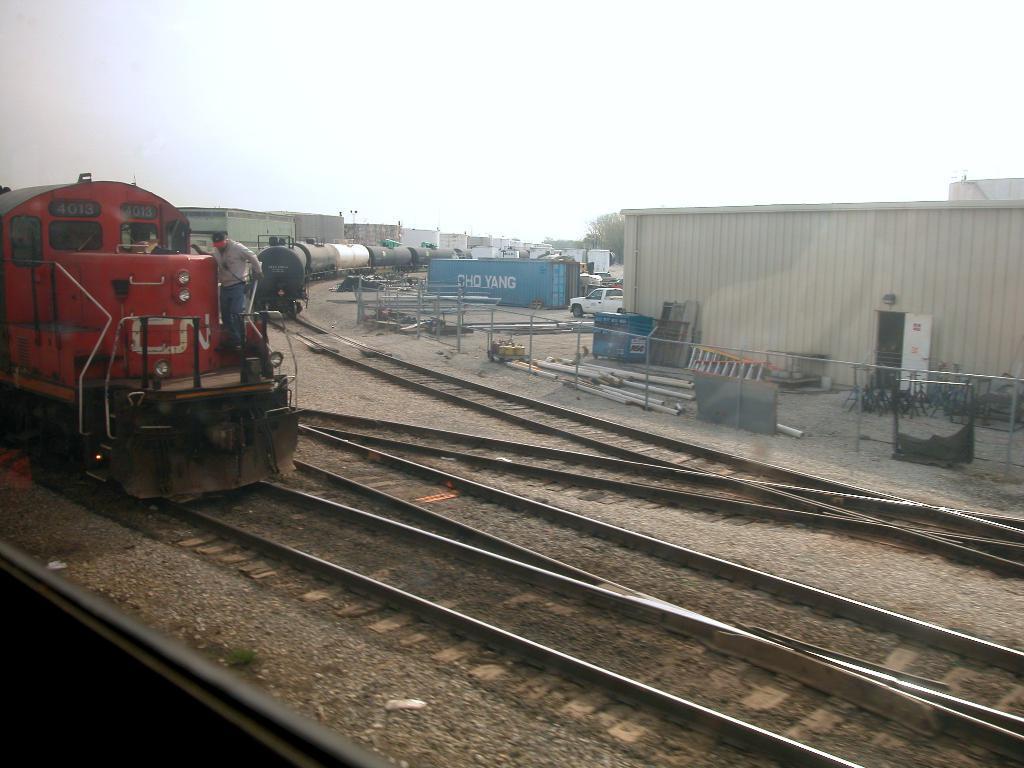In one or two sentences, can you explain what this image depicts? This picture is clicked outside. On the left we can see the trains seems to be running on the railway tracks. In the foreground we can see the gravels, metal rods and many other objects are placed on the ground and we can see a cabin. On the left we can see a person standing on the train. In the background we can see the sky, trees, buildings and many other objects and a vehicle. 